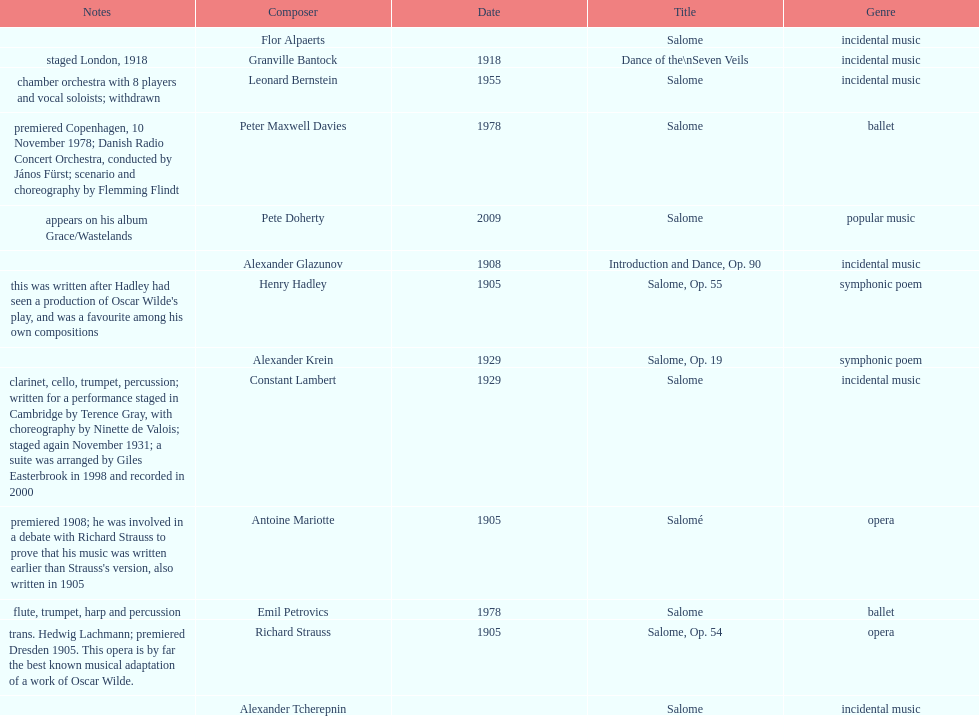Why type of genre was peter maxwell davies' work that was the same as emil petrovics' Ballet. 